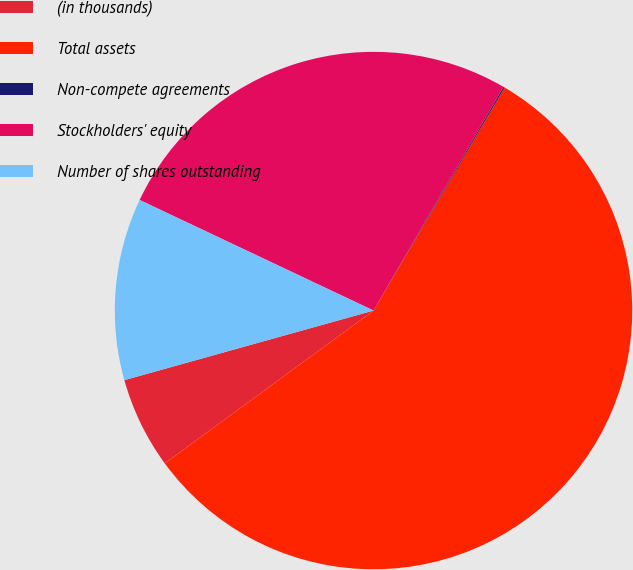Convert chart to OTSL. <chart><loc_0><loc_0><loc_500><loc_500><pie_chart><fcel>(in thousands)<fcel>Total assets<fcel>Non-compete agreements<fcel>Stockholders' equity<fcel>Number of shares outstanding<nl><fcel>5.72%<fcel>56.48%<fcel>0.08%<fcel>26.35%<fcel>11.36%<nl></chart> 